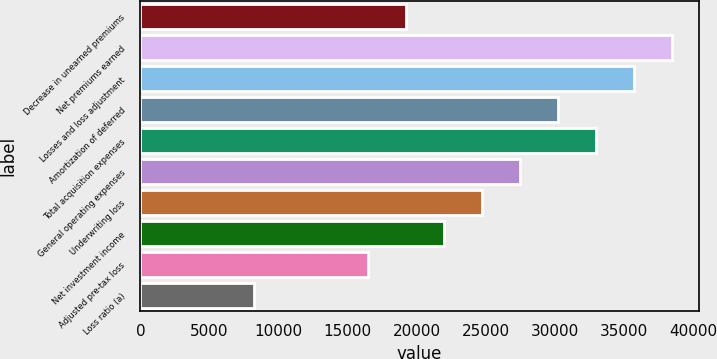<chart> <loc_0><loc_0><loc_500><loc_500><bar_chart><fcel>Decrease in unearned premiums<fcel>Net premiums earned<fcel>Losses and loss adjustment<fcel>Amortization of deferred<fcel>Total acquisition expenses<fcel>General operating expenses<fcel>Underwriting loss<fcel>Net investment income<fcel>Adjusted pre-tax loss<fcel>Loss ratio (a)<nl><fcel>19254<fcel>38506.4<fcel>35756.1<fcel>30255.3<fcel>33005.7<fcel>27505<fcel>24754.7<fcel>22004.3<fcel>16503.6<fcel>8252.55<nl></chart> 